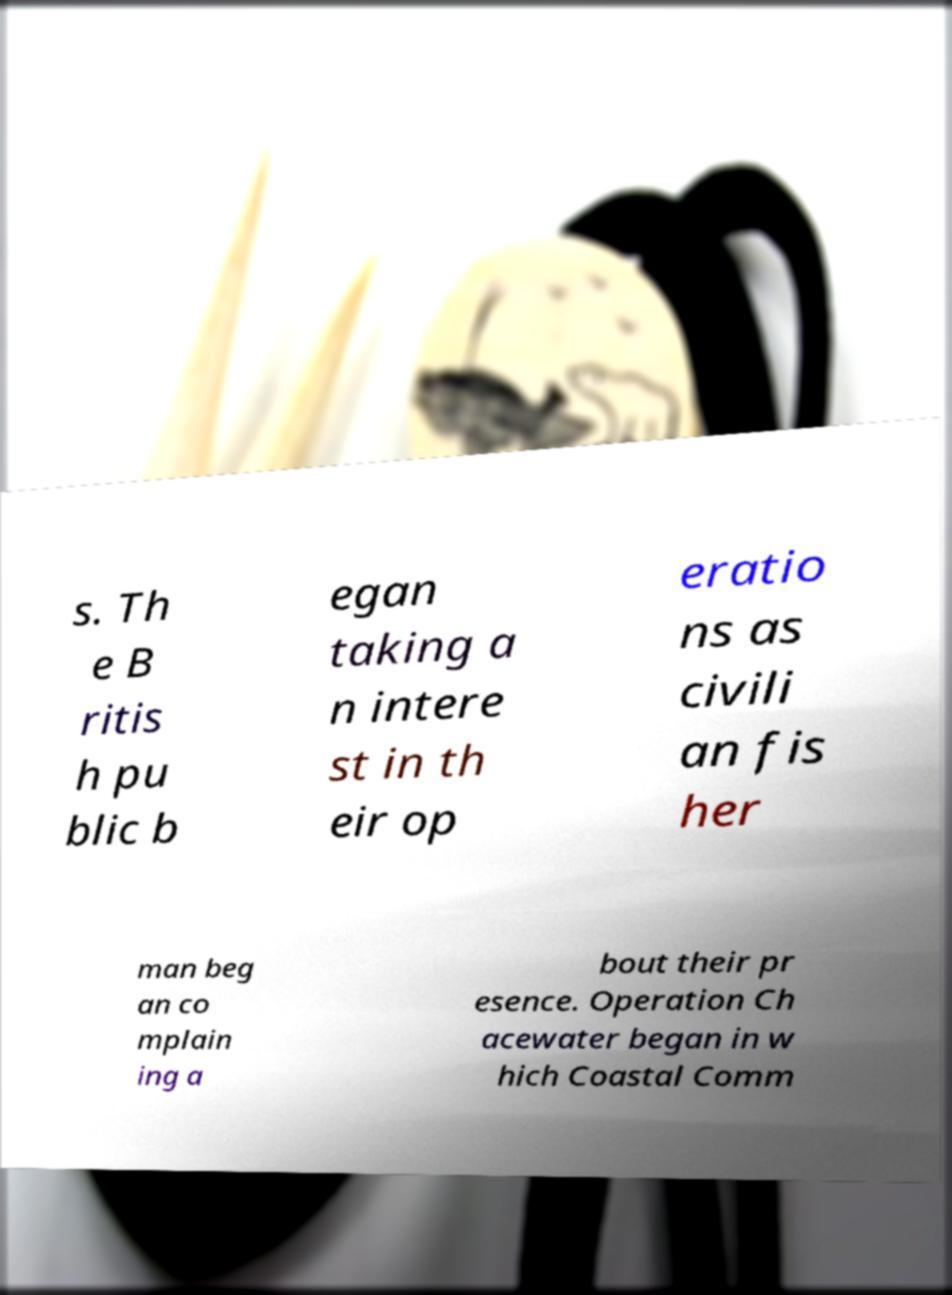I need the written content from this picture converted into text. Can you do that? s. Th e B ritis h pu blic b egan taking a n intere st in th eir op eratio ns as civili an fis her man beg an co mplain ing a bout their pr esence. Operation Ch acewater began in w hich Coastal Comm 